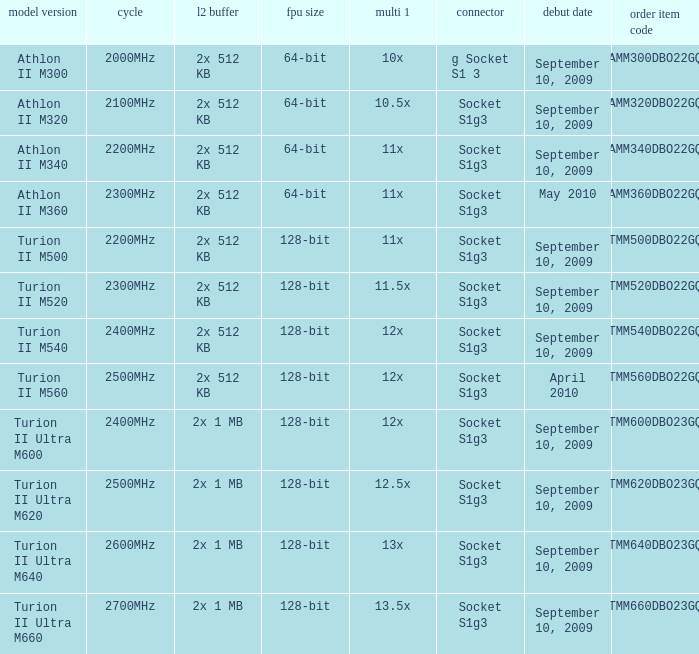What is the L2 cache with a 13.5x multi 1? 2x 1 MB. 